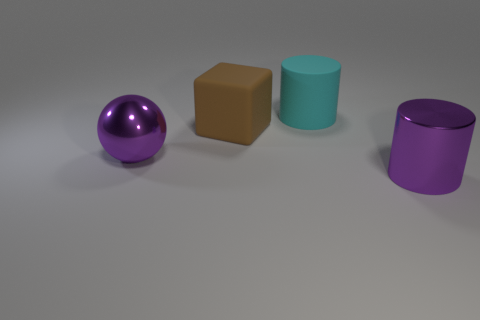Is there a ball?
Your answer should be very brief. Yes. The big purple thing behind the purple shiny object right of the metallic object that is on the left side of the metallic cylinder is made of what material?
Offer a very short reply. Metal. Is the number of cyan matte cylinders to the right of the large purple cylinder less than the number of tiny gray metallic blocks?
Offer a very short reply. No. There is a cyan thing that is the same size as the brown block; what is its material?
Offer a very short reply. Rubber. What is the size of the thing that is both in front of the large rubber block and on the right side of the big metal ball?
Offer a very short reply. Large. There is a purple object that is the same shape as the big cyan matte object; what size is it?
Provide a short and direct response. Large. What number of objects are purple balls or big things that are behind the metallic ball?
Keep it short and to the point. 3. What is the shape of the large brown matte thing?
Offer a very short reply. Cube. The purple object on the left side of the large cylinder that is right of the cyan thing is what shape?
Provide a succinct answer. Sphere. There is a big cylinder that is the same color as the sphere; what material is it?
Offer a very short reply. Metal. 